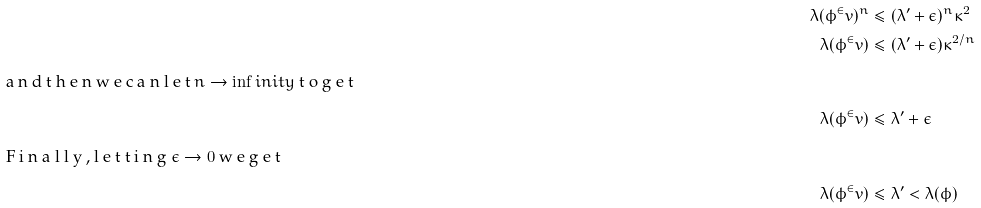Convert formula to latex. <formula><loc_0><loc_0><loc_500><loc_500>\lambda ( \phi ^ { \in } v ) ^ { n } & \leq ( \lambda ^ { \prime } + \epsilon ) ^ { n } \kappa ^ { 2 } \\ \lambda ( \phi ^ { \in } v ) & \leq ( \lambda ^ { \prime } + \epsilon ) \kappa ^ { 2 / n } \\ \intertext { a n d t h e n w e c a n l e t $ n \to \inf i n i t y $ t o g e t } \lambda ( \phi ^ { \in } v ) & \leq \lambda ^ { \prime } + \epsilon \\ \intertext { F i n a l l y , l e t t i n g $ \epsilon \to 0 $ w e g e t } \lambda ( \phi ^ { \in } v ) & \leq \lambda ^ { \prime } < \lambda ( \phi )</formula> 